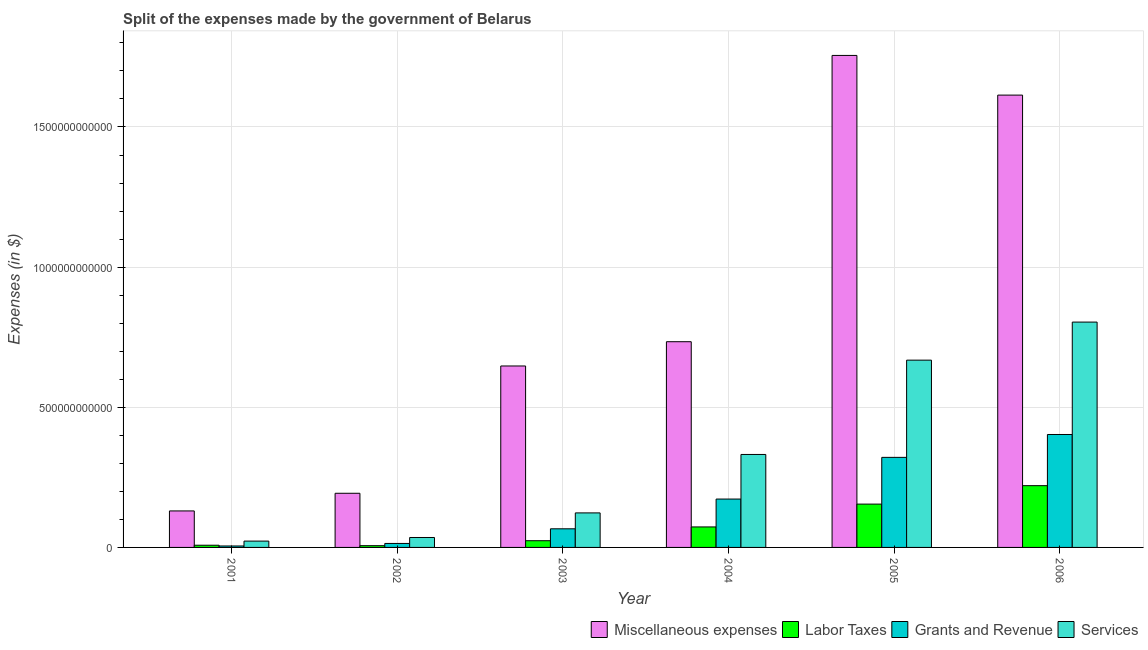How many different coloured bars are there?
Make the answer very short. 4. How many bars are there on the 2nd tick from the right?
Your response must be concise. 4. What is the label of the 1st group of bars from the left?
Offer a terse response. 2001. What is the amount spent on services in 2003?
Give a very brief answer. 1.23e+11. Across all years, what is the maximum amount spent on grants and revenue?
Provide a succinct answer. 4.03e+11. Across all years, what is the minimum amount spent on labor taxes?
Make the answer very short. 6.24e+09. In which year was the amount spent on miscellaneous expenses minimum?
Your response must be concise. 2001. What is the total amount spent on labor taxes in the graph?
Make the answer very short. 4.86e+11. What is the difference between the amount spent on grants and revenue in 2001 and that in 2002?
Your answer should be compact. -9.01e+09. What is the difference between the amount spent on labor taxes in 2003 and the amount spent on services in 2002?
Ensure brevity in your answer.  1.77e+1. What is the average amount spent on labor taxes per year?
Give a very brief answer. 8.10e+1. What is the ratio of the amount spent on miscellaneous expenses in 2002 to that in 2006?
Provide a short and direct response. 0.12. Is the difference between the amount spent on services in 2001 and 2006 greater than the difference between the amount spent on grants and revenue in 2001 and 2006?
Give a very brief answer. No. What is the difference between the highest and the second highest amount spent on grants and revenue?
Provide a short and direct response. 8.16e+1. What is the difference between the highest and the lowest amount spent on miscellaneous expenses?
Your answer should be compact. 1.63e+12. In how many years, is the amount spent on miscellaneous expenses greater than the average amount spent on miscellaneous expenses taken over all years?
Provide a succinct answer. 2. Is the sum of the amount spent on services in 2002 and 2004 greater than the maximum amount spent on labor taxes across all years?
Your answer should be compact. No. What does the 3rd bar from the left in 2002 represents?
Ensure brevity in your answer.  Grants and Revenue. What does the 4th bar from the right in 2006 represents?
Ensure brevity in your answer.  Miscellaneous expenses. How many bars are there?
Give a very brief answer. 24. Are all the bars in the graph horizontal?
Provide a succinct answer. No. How many years are there in the graph?
Provide a short and direct response. 6. What is the difference between two consecutive major ticks on the Y-axis?
Make the answer very short. 5.00e+11. Are the values on the major ticks of Y-axis written in scientific E-notation?
Offer a very short reply. No. Does the graph contain any zero values?
Offer a very short reply. No. Where does the legend appear in the graph?
Provide a succinct answer. Bottom right. What is the title of the graph?
Your response must be concise. Split of the expenses made by the government of Belarus. Does "Natural Gas" appear as one of the legend labels in the graph?
Offer a very short reply. No. What is the label or title of the X-axis?
Provide a short and direct response. Year. What is the label or title of the Y-axis?
Ensure brevity in your answer.  Expenses (in $). What is the Expenses (in $) of Miscellaneous expenses in 2001?
Your answer should be very brief. 1.30e+11. What is the Expenses (in $) of Labor Taxes in 2001?
Provide a short and direct response. 7.83e+09. What is the Expenses (in $) in Grants and Revenue in 2001?
Ensure brevity in your answer.  5.20e+09. What is the Expenses (in $) in Services in 2001?
Give a very brief answer. 2.26e+1. What is the Expenses (in $) of Miscellaneous expenses in 2002?
Your answer should be compact. 1.93e+11. What is the Expenses (in $) of Labor Taxes in 2002?
Ensure brevity in your answer.  6.24e+09. What is the Expenses (in $) in Grants and Revenue in 2002?
Provide a short and direct response. 1.42e+1. What is the Expenses (in $) of Services in 2002?
Offer a very short reply. 3.54e+1. What is the Expenses (in $) of Miscellaneous expenses in 2003?
Offer a very short reply. 6.47e+11. What is the Expenses (in $) in Labor Taxes in 2003?
Keep it short and to the point. 2.39e+1. What is the Expenses (in $) of Grants and Revenue in 2003?
Offer a very short reply. 6.65e+1. What is the Expenses (in $) of Services in 2003?
Provide a short and direct response. 1.23e+11. What is the Expenses (in $) of Miscellaneous expenses in 2004?
Offer a very short reply. 7.34e+11. What is the Expenses (in $) of Labor Taxes in 2004?
Ensure brevity in your answer.  7.31e+1. What is the Expenses (in $) in Grants and Revenue in 2004?
Give a very brief answer. 1.73e+11. What is the Expenses (in $) of Services in 2004?
Provide a succinct answer. 3.32e+11. What is the Expenses (in $) in Miscellaneous expenses in 2005?
Your response must be concise. 1.76e+12. What is the Expenses (in $) of Labor Taxes in 2005?
Your answer should be very brief. 1.55e+11. What is the Expenses (in $) in Grants and Revenue in 2005?
Offer a very short reply. 3.21e+11. What is the Expenses (in $) in Services in 2005?
Your answer should be very brief. 6.68e+11. What is the Expenses (in $) in Miscellaneous expenses in 2006?
Your answer should be very brief. 1.61e+12. What is the Expenses (in $) in Labor Taxes in 2006?
Ensure brevity in your answer.  2.20e+11. What is the Expenses (in $) of Grants and Revenue in 2006?
Offer a very short reply. 4.03e+11. What is the Expenses (in $) in Services in 2006?
Ensure brevity in your answer.  8.04e+11. Across all years, what is the maximum Expenses (in $) in Miscellaneous expenses?
Provide a succinct answer. 1.76e+12. Across all years, what is the maximum Expenses (in $) in Labor Taxes?
Your answer should be compact. 2.20e+11. Across all years, what is the maximum Expenses (in $) in Grants and Revenue?
Your answer should be very brief. 4.03e+11. Across all years, what is the maximum Expenses (in $) of Services?
Offer a very short reply. 8.04e+11. Across all years, what is the minimum Expenses (in $) of Miscellaneous expenses?
Your answer should be compact. 1.30e+11. Across all years, what is the minimum Expenses (in $) of Labor Taxes?
Your answer should be compact. 6.24e+09. Across all years, what is the minimum Expenses (in $) in Grants and Revenue?
Give a very brief answer. 5.20e+09. Across all years, what is the minimum Expenses (in $) of Services?
Offer a terse response. 2.26e+1. What is the total Expenses (in $) in Miscellaneous expenses in the graph?
Your answer should be compact. 5.07e+12. What is the total Expenses (in $) in Labor Taxes in the graph?
Your answer should be compact. 4.86e+11. What is the total Expenses (in $) in Grants and Revenue in the graph?
Your answer should be compact. 9.83e+11. What is the total Expenses (in $) of Services in the graph?
Ensure brevity in your answer.  1.98e+12. What is the difference between the Expenses (in $) of Miscellaneous expenses in 2001 and that in 2002?
Offer a terse response. -6.30e+1. What is the difference between the Expenses (in $) of Labor Taxes in 2001 and that in 2002?
Your answer should be very brief. 1.60e+09. What is the difference between the Expenses (in $) in Grants and Revenue in 2001 and that in 2002?
Offer a very short reply. -9.01e+09. What is the difference between the Expenses (in $) of Services in 2001 and that in 2002?
Ensure brevity in your answer.  -1.29e+1. What is the difference between the Expenses (in $) of Miscellaneous expenses in 2001 and that in 2003?
Your answer should be compact. -5.17e+11. What is the difference between the Expenses (in $) of Labor Taxes in 2001 and that in 2003?
Make the answer very short. -1.61e+1. What is the difference between the Expenses (in $) in Grants and Revenue in 2001 and that in 2003?
Your answer should be compact. -6.13e+1. What is the difference between the Expenses (in $) of Services in 2001 and that in 2003?
Provide a short and direct response. -1.01e+11. What is the difference between the Expenses (in $) in Miscellaneous expenses in 2001 and that in 2004?
Make the answer very short. -6.04e+11. What is the difference between the Expenses (in $) of Labor Taxes in 2001 and that in 2004?
Provide a succinct answer. -6.53e+1. What is the difference between the Expenses (in $) in Grants and Revenue in 2001 and that in 2004?
Offer a very short reply. -1.67e+11. What is the difference between the Expenses (in $) in Services in 2001 and that in 2004?
Give a very brief answer. -3.09e+11. What is the difference between the Expenses (in $) in Miscellaneous expenses in 2001 and that in 2005?
Make the answer very short. -1.63e+12. What is the difference between the Expenses (in $) of Labor Taxes in 2001 and that in 2005?
Your answer should be very brief. -1.47e+11. What is the difference between the Expenses (in $) in Grants and Revenue in 2001 and that in 2005?
Give a very brief answer. -3.16e+11. What is the difference between the Expenses (in $) of Services in 2001 and that in 2005?
Offer a terse response. -6.46e+11. What is the difference between the Expenses (in $) in Miscellaneous expenses in 2001 and that in 2006?
Your answer should be compact. -1.48e+12. What is the difference between the Expenses (in $) in Labor Taxes in 2001 and that in 2006?
Make the answer very short. -2.13e+11. What is the difference between the Expenses (in $) of Grants and Revenue in 2001 and that in 2006?
Your answer should be very brief. -3.98e+11. What is the difference between the Expenses (in $) of Services in 2001 and that in 2006?
Your answer should be compact. -7.81e+11. What is the difference between the Expenses (in $) in Miscellaneous expenses in 2002 and that in 2003?
Your answer should be compact. -4.54e+11. What is the difference between the Expenses (in $) in Labor Taxes in 2002 and that in 2003?
Your response must be concise. -1.77e+1. What is the difference between the Expenses (in $) of Grants and Revenue in 2002 and that in 2003?
Your answer should be very brief. -5.23e+1. What is the difference between the Expenses (in $) of Services in 2002 and that in 2003?
Offer a terse response. -8.77e+1. What is the difference between the Expenses (in $) of Miscellaneous expenses in 2002 and that in 2004?
Keep it short and to the point. -5.41e+11. What is the difference between the Expenses (in $) of Labor Taxes in 2002 and that in 2004?
Provide a succinct answer. -6.69e+1. What is the difference between the Expenses (in $) in Grants and Revenue in 2002 and that in 2004?
Make the answer very short. -1.58e+11. What is the difference between the Expenses (in $) of Services in 2002 and that in 2004?
Your answer should be compact. -2.96e+11. What is the difference between the Expenses (in $) of Miscellaneous expenses in 2002 and that in 2005?
Offer a very short reply. -1.56e+12. What is the difference between the Expenses (in $) in Labor Taxes in 2002 and that in 2005?
Provide a short and direct response. -1.48e+11. What is the difference between the Expenses (in $) in Grants and Revenue in 2002 and that in 2005?
Ensure brevity in your answer.  -3.07e+11. What is the difference between the Expenses (in $) of Services in 2002 and that in 2005?
Ensure brevity in your answer.  -6.33e+11. What is the difference between the Expenses (in $) of Miscellaneous expenses in 2002 and that in 2006?
Provide a succinct answer. -1.42e+12. What is the difference between the Expenses (in $) in Labor Taxes in 2002 and that in 2006?
Your answer should be very brief. -2.14e+11. What is the difference between the Expenses (in $) of Grants and Revenue in 2002 and that in 2006?
Make the answer very short. -3.89e+11. What is the difference between the Expenses (in $) of Services in 2002 and that in 2006?
Offer a very short reply. -7.68e+11. What is the difference between the Expenses (in $) in Miscellaneous expenses in 2003 and that in 2004?
Keep it short and to the point. -8.66e+1. What is the difference between the Expenses (in $) of Labor Taxes in 2003 and that in 2004?
Provide a short and direct response. -4.92e+1. What is the difference between the Expenses (in $) of Grants and Revenue in 2003 and that in 2004?
Provide a succinct answer. -1.06e+11. What is the difference between the Expenses (in $) of Services in 2003 and that in 2004?
Offer a terse response. -2.08e+11. What is the difference between the Expenses (in $) in Miscellaneous expenses in 2003 and that in 2005?
Keep it short and to the point. -1.11e+12. What is the difference between the Expenses (in $) of Labor Taxes in 2003 and that in 2005?
Offer a terse response. -1.31e+11. What is the difference between the Expenses (in $) of Grants and Revenue in 2003 and that in 2005?
Your answer should be very brief. -2.55e+11. What is the difference between the Expenses (in $) of Services in 2003 and that in 2005?
Make the answer very short. -5.45e+11. What is the difference between the Expenses (in $) in Miscellaneous expenses in 2003 and that in 2006?
Ensure brevity in your answer.  -9.66e+11. What is the difference between the Expenses (in $) of Labor Taxes in 2003 and that in 2006?
Offer a very short reply. -1.96e+11. What is the difference between the Expenses (in $) in Grants and Revenue in 2003 and that in 2006?
Provide a short and direct response. -3.36e+11. What is the difference between the Expenses (in $) of Services in 2003 and that in 2006?
Ensure brevity in your answer.  -6.81e+11. What is the difference between the Expenses (in $) of Miscellaneous expenses in 2004 and that in 2005?
Offer a very short reply. -1.02e+12. What is the difference between the Expenses (in $) of Labor Taxes in 2004 and that in 2005?
Keep it short and to the point. -8.14e+1. What is the difference between the Expenses (in $) in Grants and Revenue in 2004 and that in 2005?
Offer a terse response. -1.49e+11. What is the difference between the Expenses (in $) in Services in 2004 and that in 2005?
Your response must be concise. -3.36e+11. What is the difference between the Expenses (in $) in Miscellaneous expenses in 2004 and that in 2006?
Offer a very short reply. -8.80e+11. What is the difference between the Expenses (in $) in Labor Taxes in 2004 and that in 2006?
Offer a terse response. -1.47e+11. What is the difference between the Expenses (in $) of Grants and Revenue in 2004 and that in 2006?
Provide a short and direct response. -2.30e+11. What is the difference between the Expenses (in $) in Services in 2004 and that in 2006?
Your answer should be very brief. -4.72e+11. What is the difference between the Expenses (in $) in Miscellaneous expenses in 2005 and that in 2006?
Your answer should be compact. 1.42e+11. What is the difference between the Expenses (in $) in Labor Taxes in 2005 and that in 2006?
Your answer should be very brief. -6.58e+1. What is the difference between the Expenses (in $) in Grants and Revenue in 2005 and that in 2006?
Provide a short and direct response. -8.16e+1. What is the difference between the Expenses (in $) of Services in 2005 and that in 2006?
Provide a succinct answer. -1.36e+11. What is the difference between the Expenses (in $) of Miscellaneous expenses in 2001 and the Expenses (in $) of Labor Taxes in 2002?
Your answer should be very brief. 1.24e+11. What is the difference between the Expenses (in $) in Miscellaneous expenses in 2001 and the Expenses (in $) in Grants and Revenue in 2002?
Give a very brief answer. 1.16e+11. What is the difference between the Expenses (in $) in Miscellaneous expenses in 2001 and the Expenses (in $) in Services in 2002?
Keep it short and to the point. 9.48e+1. What is the difference between the Expenses (in $) of Labor Taxes in 2001 and the Expenses (in $) of Grants and Revenue in 2002?
Offer a terse response. -6.37e+09. What is the difference between the Expenses (in $) in Labor Taxes in 2001 and the Expenses (in $) in Services in 2002?
Provide a short and direct response. -2.76e+1. What is the difference between the Expenses (in $) in Grants and Revenue in 2001 and the Expenses (in $) in Services in 2002?
Keep it short and to the point. -3.02e+1. What is the difference between the Expenses (in $) of Miscellaneous expenses in 2001 and the Expenses (in $) of Labor Taxes in 2003?
Give a very brief answer. 1.06e+11. What is the difference between the Expenses (in $) of Miscellaneous expenses in 2001 and the Expenses (in $) of Grants and Revenue in 2003?
Keep it short and to the point. 6.37e+1. What is the difference between the Expenses (in $) of Miscellaneous expenses in 2001 and the Expenses (in $) of Services in 2003?
Make the answer very short. 7.04e+09. What is the difference between the Expenses (in $) of Labor Taxes in 2001 and the Expenses (in $) of Grants and Revenue in 2003?
Your answer should be compact. -5.86e+1. What is the difference between the Expenses (in $) of Labor Taxes in 2001 and the Expenses (in $) of Services in 2003?
Provide a short and direct response. -1.15e+11. What is the difference between the Expenses (in $) in Grants and Revenue in 2001 and the Expenses (in $) in Services in 2003?
Your answer should be compact. -1.18e+11. What is the difference between the Expenses (in $) of Miscellaneous expenses in 2001 and the Expenses (in $) of Labor Taxes in 2004?
Provide a succinct answer. 5.71e+1. What is the difference between the Expenses (in $) in Miscellaneous expenses in 2001 and the Expenses (in $) in Grants and Revenue in 2004?
Make the answer very short. -4.24e+1. What is the difference between the Expenses (in $) in Miscellaneous expenses in 2001 and the Expenses (in $) in Services in 2004?
Your answer should be very brief. -2.01e+11. What is the difference between the Expenses (in $) in Labor Taxes in 2001 and the Expenses (in $) in Grants and Revenue in 2004?
Keep it short and to the point. -1.65e+11. What is the difference between the Expenses (in $) of Labor Taxes in 2001 and the Expenses (in $) of Services in 2004?
Provide a short and direct response. -3.24e+11. What is the difference between the Expenses (in $) in Grants and Revenue in 2001 and the Expenses (in $) in Services in 2004?
Offer a very short reply. -3.26e+11. What is the difference between the Expenses (in $) of Miscellaneous expenses in 2001 and the Expenses (in $) of Labor Taxes in 2005?
Offer a terse response. -2.43e+1. What is the difference between the Expenses (in $) of Miscellaneous expenses in 2001 and the Expenses (in $) of Grants and Revenue in 2005?
Keep it short and to the point. -1.91e+11. What is the difference between the Expenses (in $) in Miscellaneous expenses in 2001 and the Expenses (in $) in Services in 2005?
Keep it short and to the point. -5.38e+11. What is the difference between the Expenses (in $) in Labor Taxes in 2001 and the Expenses (in $) in Grants and Revenue in 2005?
Provide a short and direct response. -3.13e+11. What is the difference between the Expenses (in $) in Labor Taxes in 2001 and the Expenses (in $) in Services in 2005?
Offer a terse response. -6.60e+11. What is the difference between the Expenses (in $) in Grants and Revenue in 2001 and the Expenses (in $) in Services in 2005?
Offer a terse response. -6.63e+11. What is the difference between the Expenses (in $) of Miscellaneous expenses in 2001 and the Expenses (in $) of Labor Taxes in 2006?
Your response must be concise. -9.02e+1. What is the difference between the Expenses (in $) of Miscellaneous expenses in 2001 and the Expenses (in $) of Grants and Revenue in 2006?
Ensure brevity in your answer.  -2.73e+11. What is the difference between the Expenses (in $) of Miscellaneous expenses in 2001 and the Expenses (in $) of Services in 2006?
Keep it short and to the point. -6.74e+11. What is the difference between the Expenses (in $) in Labor Taxes in 2001 and the Expenses (in $) in Grants and Revenue in 2006?
Offer a very short reply. -3.95e+11. What is the difference between the Expenses (in $) in Labor Taxes in 2001 and the Expenses (in $) in Services in 2006?
Provide a short and direct response. -7.96e+11. What is the difference between the Expenses (in $) of Grants and Revenue in 2001 and the Expenses (in $) of Services in 2006?
Provide a short and direct response. -7.99e+11. What is the difference between the Expenses (in $) in Miscellaneous expenses in 2002 and the Expenses (in $) in Labor Taxes in 2003?
Provide a succinct answer. 1.69e+11. What is the difference between the Expenses (in $) in Miscellaneous expenses in 2002 and the Expenses (in $) in Grants and Revenue in 2003?
Your answer should be very brief. 1.27e+11. What is the difference between the Expenses (in $) of Miscellaneous expenses in 2002 and the Expenses (in $) of Services in 2003?
Make the answer very short. 7.00e+1. What is the difference between the Expenses (in $) of Labor Taxes in 2002 and the Expenses (in $) of Grants and Revenue in 2003?
Provide a succinct answer. -6.02e+1. What is the difference between the Expenses (in $) in Labor Taxes in 2002 and the Expenses (in $) in Services in 2003?
Offer a terse response. -1.17e+11. What is the difference between the Expenses (in $) of Grants and Revenue in 2002 and the Expenses (in $) of Services in 2003?
Your answer should be very brief. -1.09e+11. What is the difference between the Expenses (in $) in Miscellaneous expenses in 2002 and the Expenses (in $) in Labor Taxes in 2004?
Give a very brief answer. 1.20e+11. What is the difference between the Expenses (in $) in Miscellaneous expenses in 2002 and the Expenses (in $) in Grants and Revenue in 2004?
Make the answer very short. 2.06e+1. What is the difference between the Expenses (in $) in Miscellaneous expenses in 2002 and the Expenses (in $) in Services in 2004?
Provide a succinct answer. -1.38e+11. What is the difference between the Expenses (in $) in Labor Taxes in 2002 and the Expenses (in $) in Grants and Revenue in 2004?
Your answer should be compact. -1.66e+11. What is the difference between the Expenses (in $) of Labor Taxes in 2002 and the Expenses (in $) of Services in 2004?
Make the answer very short. -3.25e+11. What is the difference between the Expenses (in $) of Grants and Revenue in 2002 and the Expenses (in $) of Services in 2004?
Ensure brevity in your answer.  -3.17e+11. What is the difference between the Expenses (in $) of Miscellaneous expenses in 2002 and the Expenses (in $) of Labor Taxes in 2005?
Ensure brevity in your answer.  3.86e+1. What is the difference between the Expenses (in $) in Miscellaneous expenses in 2002 and the Expenses (in $) in Grants and Revenue in 2005?
Ensure brevity in your answer.  -1.28e+11. What is the difference between the Expenses (in $) of Miscellaneous expenses in 2002 and the Expenses (in $) of Services in 2005?
Offer a very short reply. -4.75e+11. What is the difference between the Expenses (in $) in Labor Taxes in 2002 and the Expenses (in $) in Grants and Revenue in 2005?
Keep it short and to the point. -3.15e+11. What is the difference between the Expenses (in $) of Labor Taxes in 2002 and the Expenses (in $) of Services in 2005?
Offer a very short reply. -6.62e+11. What is the difference between the Expenses (in $) of Grants and Revenue in 2002 and the Expenses (in $) of Services in 2005?
Your answer should be compact. -6.54e+11. What is the difference between the Expenses (in $) of Miscellaneous expenses in 2002 and the Expenses (in $) of Labor Taxes in 2006?
Ensure brevity in your answer.  -2.72e+1. What is the difference between the Expenses (in $) in Miscellaneous expenses in 2002 and the Expenses (in $) in Grants and Revenue in 2006?
Your answer should be very brief. -2.10e+11. What is the difference between the Expenses (in $) in Miscellaneous expenses in 2002 and the Expenses (in $) in Services in 2006?
Your answer should be compact. -6.11e+11. What is the difference between the Expenses (in $) of Labor Taxes in 2002 and the Expenses (in $) of Grants and Revenue in 2006?
Make the answer very short. -3.97e+11. What is the difference between the Expenses (in $) of Labor Taxes in 2002 and the Expenses (in $) of Services in 2006?
Offer a very short reply. -7.98e+11. What is the difference between the Expenses (in $) of Grants and Revenue in 2002 and the Expenses (in $) of Services in 2006?
Make the answer very short. -7.90e+11. What is the difference between the Expenses (in $) in Miscellaneous expenses in 2003 and the Expenses (in $) in Labor Taxes in 2004?
Provide a succinct answer. 5.74e+11. What is the difference between the Expenses (in $) of Miscellaneous expenses in 2003 and the Expenses (in $) of Grants and Revenue in 2004?
Make the answer very short. 4.75e+11. What is the difference between the Expenses (in $) of Miscellaneous expenses in 2003 and the Expenses (in $) of Services in 2004?
Your answer should be compact. 3.16e+11. What is the difference between the Expenses (in $) of Labor Taxes in 2003 and the Expenses (in $) of Grants and Revenue in 2004?
Ensure brevity in your answer.  -1.49e+11. What is the difference between the Expenses (in $) of Labor Taxes in 2003 and the Expenses (in $) of Services in 2004?
Your answer should be compact. -3.08e+11. What is the difference between the Expenses (in $) of Grants and Revenue in 2003 and the Expenses (in $) of Services in 2004?
Give a very brief answer. -2.65e+11. What is the difference between the Expenses (in $) of Miscellaneous expenses in 2003 and the Expenses (in $) of Labor Taxes in 2005?
Keep it short and to the point. 4.93e+11. What is the difference between the Expenses (in $) in Miscellaneous expenses in 2003 and the Expenses (in $) in Grants and Revenue in 2005?
Your answer should be very brief. 3.26e+11. What is the difference between the Expenses (in $) in Miscellaneous expenses in 2003 and the Expenses (in $) in Services in 2005?
Make the answer very short. -2.08e+1. What is the difference between the Expenses (in $) in Labor Taxes in 2003 and the Expenses (in $) in Grants and Revenue in 2005?
Your response must be concise. -2.97e+11. What is the difference between the Expenses (in $) of Labor Taxes in 2003 and the Expenses (in $) of Services in 2005?
Your response must be concise. -6.44e+11. What is the difference between the Expenses (in $) of Grants and Revenue in 2003 and the Expenses (in $) of Services in 2005?
Make the answer very short. -6.02e+11. What is the difference between the Expenses (in $) of Miscellaneous expenses in 2003 and the Expenses (in $) of Labor Taxes in 2006?
Give a very brief answer. 4.27e+11. What is the difference between the Expenses (in $) in Miscellaneous expenses in 2003 and the Expenses (in $) in Grants and Revenue in 2006?
Your answer should be very brief. 2.44e+11. What is the difference between the Expenses (in $) of Miscellaneous expenses in 2003 and the Expenses (in $) of Services in 2006?
Make the answer very short. -1.57e+11. What is the difference between the Expenses (in $) of Labor Taxes in 2003 and the Expenses (in $) of Grants and Revenue in 2006?
Keep it short and to the point. -3.79e+11. What is the difference between the Expenses (in $) in Labor Taxes in 2003 and the Expenses (in $) in Services in 2006?
Provide a succinct answer. -7.80e+11. What is the difference between the Expenses (in $) in Grants and Revenue in 2003 and the Expenses (in $) in Services in 2006?
Give a very brief answer. -7.37e+11. What is the difference between the Expenses (in $) in Miscellaneous expenses in 2004 and the Expenses (in $) in Labor Taxes in 2005?
Give a very brief answer. 5.79e+11. What is the difference between the Expenses (in $) in Miscellaneous expenses in 2004 and the Expenses (in $) in Grants and Revenue in 2005?
Ensure brevity in your answer.  4.13e+11. What is the difference between the Expenses (in $) in Miscellaneous expenses in 2004 and the Expenses (in $) in Services in 2005?
Ensure brevity in your answer.  6.58e+1. What is the difference between the Expenses (in $) in Labor Taxes in 2004 and the Expenses (in $) in Grants and Revenue in 2005?
Make the answer very short. -2.48e+11. What is the difference between the Expenses (in $) in Labor Taxes in 2004 and the Expenses (in $) in Services in 2005?
Ensure brevity in your answer.  -5.95e+11. What is the difference between the Expenses (in $) in Grants and Revenue in 2004 and the Expenses (in $) in Services in 2005?
Ensure brevity in your answer.  -4.96e+11. What is the difference between the Expenses (in $) in Miscellaneous expenses in 2004 and the Expenses (in $) in Labor Taxes in 2006?
Provide a succinct answer. 5.14e+11. What is the difference between the Expenses (in $) in Miscellaneous expenses in 2004 and the Expenses (in $) in Grants and Revenue in 2006?
Ensure brevity in your answer.  3.31e+11. What is the difference between the Expenses (in $) in Miscellaneous expenses in 2004 and the Expenses (in $) in Services in 2006?
Provide a short and direct response. -7.00e+1. What is the difference between the Expenses (in $) in Labor Taxes in 2004 and the Expenses (in $) in Grants and Revenue in 2006?
Give a very brief answer. -3.30e+11. What is the difference between the Expenses (in $) of Labor Taxes in 2004 and the Expenses (in $) of Services in 2006?
Keep it short and to the point. -7.31e+11. What is the difference between the Expenses (in $) of Grants and Revenue in 2004 and the Expenses (in $) of Services in 2006?
Provide a succinct answer. -6.31e+11. What is the difference between the Expenses (in $) in Miscellaneous expenses in 2005 and the Expenses (in $) in Labor Taxes in 2006?
Keep it short and to the point. 1.53e+12. What is the difference between the Expenses (in $) in Miscellaneous expenses in 2005 and the Expenses (in $) in Grants and Revenue in 2006?
Ensure brevity in your answer.  1.35e+12. What is the difference between the Expenses (in $) in Miscellaneous expenses in 2005 and the Expenses (in $) in Services in 2006?
Your answer should be very brief. 9.51e+11. What is the difference between the Expenses (in $) in Labor Taxes in 2005 and the Expenses (in $) in Grants and Revenue in 2006?
Your response must be concise. -2.48e+11. What is the difference between the Expenses (in $) in Labor Taxes in 2005 and the Expenses (in $) in Services in 2006?
Keep it short and to the point. -6.49e+11. What is the difference between the Expenses (in $) of Grants and Revenue in 2005 and the Expenses (in $) of Services in 2006?
Provide a succinct answer. -4.83e+11. What is the average Expenses (in $) in Miscellaneous expenses per year?
Keep it short and to the point. 8.46e+11. What is the average Expenses (in $) of Labor Taxes per year?
Keep it short and to the point. 8.10e+1. What is the average Expenses (in $) in Grants and Revenue per year?
Provide a short and direct response. 1.64e+11. What is the average Expenses (in $) of Services per year?
Provide a short and direct response. 3.31e+11. In the year 2001, what is the difference between the Expenses (in $) in Miscellaneous expenses and Expenses (in $) in Labor Taxes?
Ensure brevity in your answer.  1.22e+11. In the year 2001, what is the difference between the Expenses (in $) of Miscellaneous expenses and Expenses (in $) of Grants and Revenue?
Your answer should be compact. 1.25e+11. In the year 2001, what is the difference between the Expenses (in $) in Miscellaneous expenses and Expenses (in $) in Services?
Offer a terse response. 1.08e+11. In the year 2001, what is the difference between the Expenses (in $) in Labor Taxes and Expenses (in $) in Grants and Revenue?
Offer a terse response. 2.63e+09. In the year 2001, what is the difference between the Expenses (in $) of Labor Taxes and Expenses (in $) of Services?
Ensure brevity in your answer.  -1.47e+1. In the year 2001, what is the difference between the Expenses (in $) of Grants and Revenue and Expenses (in $) of Services?
Ensure brevity in your answer.  -1.74e+1. In the year 2002, what is the difference between the Expenses (in $) of Miscellaneous expenses and Expenses (in $) of Labor Taxes?
Keep it short and to the point. 1.87e+11. In the year 2002, what is the difference between the Expenses (in $) in Miscellaneous expenses and Expenses (in $) in Grants and Revenue?
Your answer should be very brief. 1.79e+11. In the year 2002, what is the difference between the Expenses (in $) of Miscellaneous expenses and Expenses (in $) of Services?
Ensure brevity in your answer.  1.58e+11. In the year 2002, what is the difference between the Expenses (in $) of Labor Taxes and Expenses (in $) of Grants and Revenue?
Provide a succinct answer. -7.97e+09. In the year 2002, what is the difference between the Expenses (in $) in Labor Taxes and Expenses (in $) in Services?
Your answer should be very brief. -2.92e+1. In the year 2002, what is the difference between the Expenses (in $) in Grants and Revenue and Expenses (in $) in Services?
Provide a succinct answer. -2.12e+1. In the year 2003, what is the difference between the Expenses (in $) of Miscellaneous expenses and Expenses (in $) of Labor Taxes?
Your answer should be compact. 6.23e+11. In the year 2003, what is the difference between the Expenses (in $) in Miscellaneous expenses and Expenses (in $) in Grants and Revenue?
Offer a very short reply. 5.81e+11. In the year 2003, what is the difference between the Expenses (in $) of Miscellaneous expenses and Expenses (in $) of Services?
Make the answer very short. 5.24e+11. In the year 2003, what is the difference between the Expenses (in $) of Labor Taxes and Expenses (in $) of Grants and Revenue?
Your answer should be very brief. -4.25e+1. In the year 2003, what is the difference between the Expenses (in $) in Labor Taxes and Expenses (in $) in Services?
Keep it short and to the point. -9.92e+1. In the year 2003, what is the difference between the Expenses (in $) of Grants and Revenue and Expenses (in $) of Services?
Make the answer very short. -5.67e+1. In the year 2004, what is the difference between the Expenses (in $) in Miscellaneous expenses and Expenses (in $) in Labor Taxes?
Offer a terse response. 6.61e+11. In the year 2004, what is the difference between the Expenses (in $) in Miscellaneous expenses and Expenses (in $) in Grants and Revenue?
Provide a short and direct response. 5.61e+11. In the year 2004, what is the difference between the Expenses (in $) in Miscellaneous expenses and Expenses (in $) in Services?
Give a very brief answer. 4.02e+11. In the year 2004, what is the difference between the Expenses (in $) of Labor Taxes and Expenses (in $) of Grants and Revenue?
Give a very brief answer. -9.95e+1. In the year 2004, what is the difference between the Expenses (in $) in Labor Taxes and Expenses (in $) in Services?
Keep it short and to the point. -2.59e+11. In the year 2004, what is the difference between the Expenses (in $) in Grants and Revenue and Expenses (in $) in Services?
Offer a terse response. -1.59e+11. In the year 2005, what is the difference between the Expenses (in $) of Miscellaneous expenses and Expenses (in $) of Labor Taxes?
Offer a terse response. 1.60e+12. In the year 2005, what is the difference between the Expenses (in $) in Miscellaneous expenses and Expenses (in $) in Grants and Revenue?
Ensure brevity in your answer.  1.43e+12. In the year 2005, what is the difference between the Expenses (in $) of Miscellaneous expenses and Expenses (in $) of Services?
Make the answer very short. 1.09e+12. In the year 2005, what is the difference between the Expenses (in $) in Labor Taxes and Expenses (in $) in Grants and Revenue?
Give a very brief answer. -1.67e+11. In the year 2005, what is the difference between the Expenses (in $) of Labor Taxes and Expenses (in $) of Services?
Ensure brevity in your answer.  -5.14e+11. In the year 2005, what is the difference between the Expenses (in $) in Grants and Revenue and Expenses (in $) in Services?
Give a very brief answer. -3.47e+11. In the year 2006, what is the difference between the Expenses (in $) of Miscellaneous expenses and Expenses (in $) of Labor Taxes?
Provide a short and direct response. 1.39e+12. In the year 2006, what is the difference between the Expenses (in $) of Miscellaneous expenses and Expenses (in $) of Grants and Revenue?
Ensure brevity in your answer.  1.21e+12. In the year 2006, what is the difference between the Expenses (in $) in Miscellaneous expenses and Expenses (in $) in Services?
Make the answer very short. 8.10e+11. In the year 2006, what is the difference between the Expenses (in $) in Labor Taxes and Expenses (in $) in Grants and Revenue?
Make the answer very short. -1.83e+11. In the year 2006, what is the difference between the Expenses (in $) in Labor Taxes and Expenses (in $) in Services?
Keep it short and to the point. -5.84e+11. In the year 2006, what is the difference between the Expenses (in $) of Grants and Revenue and Expenses (in $) of Services?
Provide a short and direct response. -4.01e+11. What is the ratio of the Expenses (in $) of Miscellaneous expenses in 2001 to that in 2002?
Your answer should be compact. 0.67. What is the ratio of the Expenses (in $) in Labor Taxes in 2001 to that in 2002?
Ensure brevity in your answer.  1.26. What is the ratio of the Expenses (in $) in Grants and Revenue in 2001 to that in 2002?
Provide a short and direct response. 0.37. What is the ratio of the Expenses (in $) of Services in 2001 to that in 2002?
Your response must be concise. 0.64. What is the ratio of the Expenses (in $) of Miscellaneous expenses in 2001 to that in 2003?
Provide a succinct answer. 0.2. What is the ratio of the Expenses (in $) of Labor Taxes in 2001 to that in 2003?
Give a very brief answer. 0.33. What is the ratio of the Expenses (in $) in Grants and Revenue in 2001 to that in 2003?
Offer a terse response. 0.08. What is the ratio of the Expenses (in $) of Services in 2001 to that in 2003?
Your answer should be very brief. 0.18. What is the ratio of the Expenses (in $) of Miscellaneous expenses in 2001 to that in 2004?
Your response must be concise. 0.18. What is the ratio of the Expenses (in $) of Labor Taxes in 2001 to that in 2004?
Make the answer very short. 0.11. What is the ratio of the Expenses (in $) of Grants and Revenue in 2001 to that in 2004?
Give a very brief answer. 0.03. What is the ratio of the Expenses (in $) in Services in 2001 to that in 2004?
Offer a terse response. 0.07. What is the ratio of the Expenses (in $) in Miscellaneous expenses in 2001 to that in 2005?
Provide a short and direct response. 0.07. What is the ratio of the Expenses (in $) in Labor Taxes in 2001 to that in 2005?
Provide a succinct answer. 0.05. What is the ratio of the Expenses (in $) in Grants and Revenue in 2001 to that in 2005?
Make the answer very short. 0.02. What is the ratio of the Expenses (in $) in Services in 2001 to that in 2005?
Make the answer very short. 0.03. What is the ratio of the Expenses (in $) of Miscellaneous expenses in 2001 to that in 2006?
Ensure brevity in your answer.  0.08. What is the ratio of the Expenses (in $) in Labor Taxes in 2001 to that in 2006?
Make the answer very short. 0.04. What is the ratio of the Expenses (in $) of Grants and Revenue in 2001 to that in 2006?
Provide a short and direct response. 0.01. What is the ratio of the Expenses (in $) of Services in 2001 to that in 2006?
Keep it short and to the point. 0.03. What is the ratio of the Expenses (in $) in Miscellaneous expenses in 2002 to that in 2003?
Offer a very short reply. 0.3. What is the ratio of the Expenses (in $) of Labor Taxes in 2002 to that in 2003?
Your response must be concise. 0.26. What is the ratio of the Expenses (in $) in Grants and Revenue in 2002 to that in 2003?
Provide a short and direct response. 0.21. What is the ratio of the Expenses (in $) in Services in 2002 to that in 2003?
Offer a terse response. 0.29. What is the ratio of the Expenses (in $) in Miscellaneous expenses in 2002 to that in 2004?
Make the answer very short. 0.26. What is the ratio of the Expenses (in $) in Labor Taxes in 2002 to that in 2004?
Make the answer very short. 0.09. What is the ratio of the Expenses (in $) in Grants and Revenue in 2002 to that in 2004?
Keep it short and to the point. 0.08. What is the ratio of the Expenses (in $) in Services in 2002 to that in 2004?
Offer a very short reply. 0.11. What is the ratio of the Expenses (in $) of Miscellaneous expenses in 2002 to that in 2005?
Your answer should be compact. 0.11. What is the ratio of the Expenses (in $) in Labor Taxes in 2002 to that in 2005?
Give a very brief answer. 0.04. What is the ratio of the Expenses (in $) of Grants and Revenue in 2002 to that in 2005?
Provide a succinct answer. 0.04. What is the ratio of the Expenses (in $) of Services in 2002 to that in 2005?
Offer a very short reply. 0.05. What is the ratio of the Expenses (in $) of Miscellaneous expenses in 2002 to that in 2006?
Your answer should be very brief. 0.12. What is the ratio of the Expenses (in $) of Labor Taxes in 2002 to that in 2006?
Ensure brevity in your answer.  0.03. What is the ratio of the Expenses (in $) of Grants and Revenue in 2002 to that in 2006?
Your response must be concise. 0.04. What is the ratio of the Expenses (in $) in Services in 2002 to that in 2006?
Your response must be concise. 0.04. What is the ratio of the Expenses (in $) in Miscellaneous expenses in 2003 to that in 2004?
Offer a very short reply. 0.88. What is the ratio of the Expenses (in $) in Labor Taxes in 2003 to that in 2004?
Offer a terse response. 0.33. What is the ratio of the Expenses (in $) in Grants and Revenue in 2003 to that in 2004?
Offer a terse response. 0.39. What is the ratio of the Expenses (in $) of Services in 2003 to that in 2004?
Your response must be concise. 0.37. What is the ratio of the Expenses (in $) of Miscellaneous expenses in 2003 to that in 2005?
Make the answer very short. 0.37. What is the ratio of the Expenses (in $) in Labor Taxes in 2003 to that in 2005?
Your answer should be very brief. 0.15. What is the ratio of the Expenses (in $) in Grants and Revenue in 2003 to that in 2005?
Offer a very short reply. 0.21. What is the ratio of the Expenses (in $) of Services in 2003 to that in 2005?
Provide a succinct answer. 0.18. What is the ratio of the Expenses (in $) in Miscellaneous expenses in 2003 to that in 2006?
Make the answer very short. 0.4. What is the ratio of the Expenses (in $) of Labor Taxes in 2003 to that in 2006?
Ensure brevity in your answer.  0.11. What is the ratio of the Expenses (in $) of Grants and Revenue in 2003 to that in 2006?
Your response must be concise. 0.17. What is the ratio of the Expenses (in $) of Services in 2003 to that in 2006?
Your response must be concise. 0.15. What is the ratio of the Expenses (in $) in Miscellaneous expenses in 2004 to that in 2005?
Your response must be concise. 0.42. What is the ratio of the Expenses (in $) in Labor Taxes in 2004 to that in 2005?
Provide a succinct answer. 0.47. What is the ratio of the Expenses (in $) in Grants and Revenue in 2004 to that in 2005?
Ensure brevity in your answer.  0.54. What is the ratio of the Expenses (in $) of Services in 2004 to that in 2005?
Make the answer very short. 0.5. What is the ratio of the Expenses (in $) of Miscellaneous expenses in 2004 to that in 2006?
Offer a very short reply. 0.45. What is the ratio of the Expenses (in $) of Labor Taxes in 2004 to that in 2006?
Ensure brevity in your answer.  0.33. What is the ratio of the Expenses (in $) of Grants and Revenue in 2004 to that in 2006?
Your answer should be compact. 0.43. What is the ratio of the Expenses (in $) in Services in 2004 to that in 2006?
Offer a very short reply. 0.41. What is the ratio of the Expenses (in $) in Miscellaneous expenses in 2005 to that in 2006?
Offer a very short reply. 1.09. What is the ratio of the Expenses (in $) of Labor Taxes in 2005 to that in 2006?
Ensure brevity in your answer.  0.7. What is the ratio of the Expenses (in $) of Grants and Revenue in 2005 to that in 2006?
Your response must be concise. 0.8. What is the ratio of the Expenses (in $) in Services in 2005 to that in 2006?
Your answer should be compact. 0.83. What is the difference between the highest and the second highest Expenses (in $) of Miscellaneous expenses?
Give a very brief answer. 1.42e+11. What is the difference between the highest and the second highest Expenses (in $) of Labor Taxes?
Offer a very short reply. 6.58e+1. What is the difference between the highest and the second highest Expenses (in $) of Grants and Revenue?
Provide a short and direct response. 8.16e+1. What is the difference between the highest and the second highest Expenses (in $) in Services?
Ensure brevity in your answer.  1.36e+11. What is the difference between the highest and the lowest Expenses (in $) in Miscellaneous expenses?
Provide a short and direct response. 1.63e+12. What is the difference between the highest and the lowest Expenses (in $) of Labor Taxes?
Your answer should be compact. 2.14e+11. What is the difference between the highest and the lowest Expenses (in $) in Grants and Revenue?
Make the answer very short. 3.98e+11. What is the difference between the highest and the lowest Expenses (in $) of Services?
Offer a terse response. 7.81e+11. 